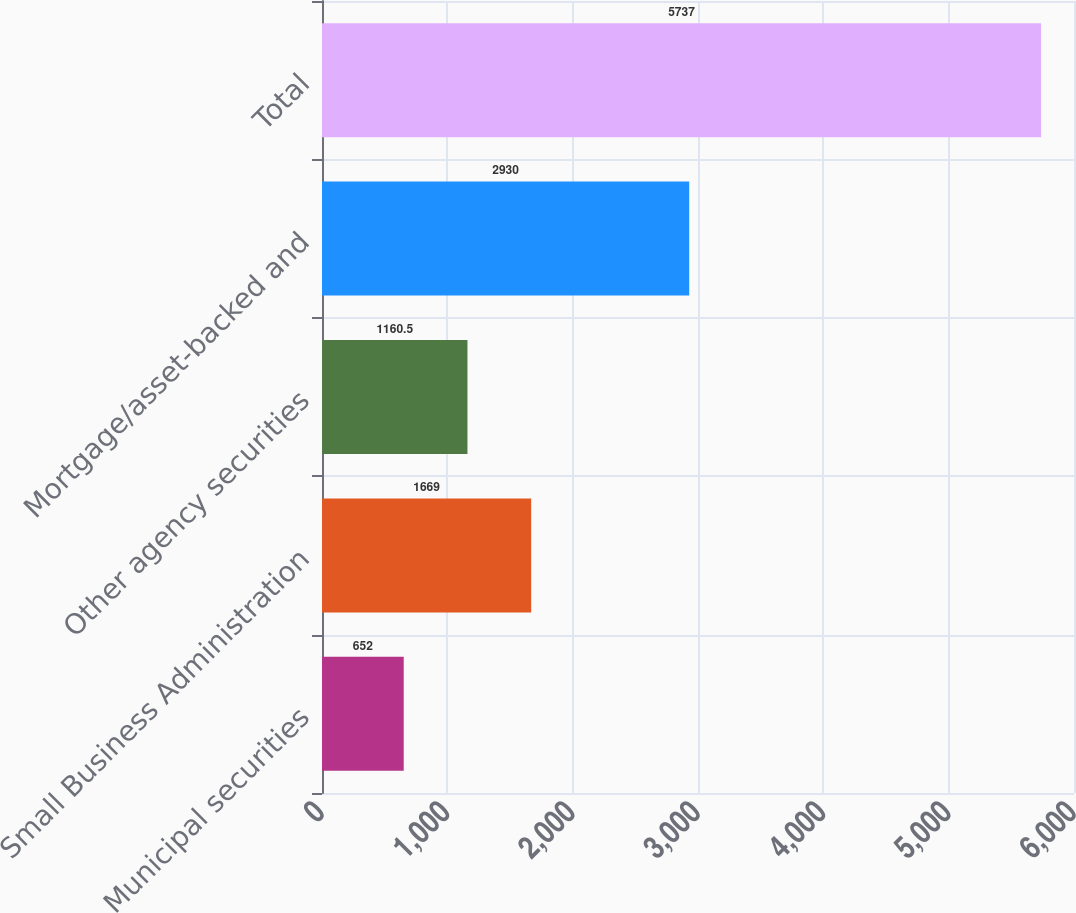Convert chart. <chart><loc_0><loc_0><loc_500><loc_500><bar_chart><fcel>Municipal securities<fcel>Small Business Administration<fcel>Other agency securities<fcel>Mortgage/asset-backed and<fcel>Total<nl><fcel>652<fcel>1669<fcel>1160.5<fcel>2930<fcel>5737<nl></chart> 